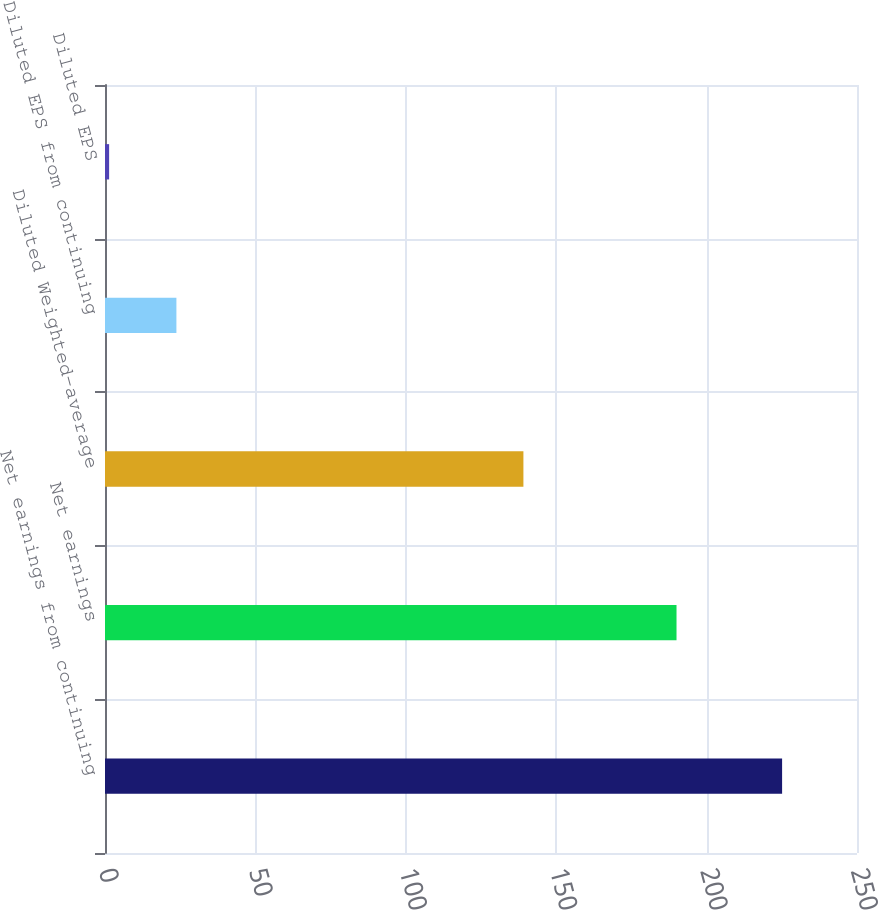Convert chart. <chart><loc_0><loc_0><loc_500><loc_500><bar_chart><fcel>Net earnings from continuing<fcel>Net earnings<fcel>Diluted Weighted-average<fcel>Diluted EPS from continuing<fcel>Diluted EPS<nl><fcel>225.1<fcel>190<fcel>139.1<fcel>23.74<fcel>1.37<nl></chart> 